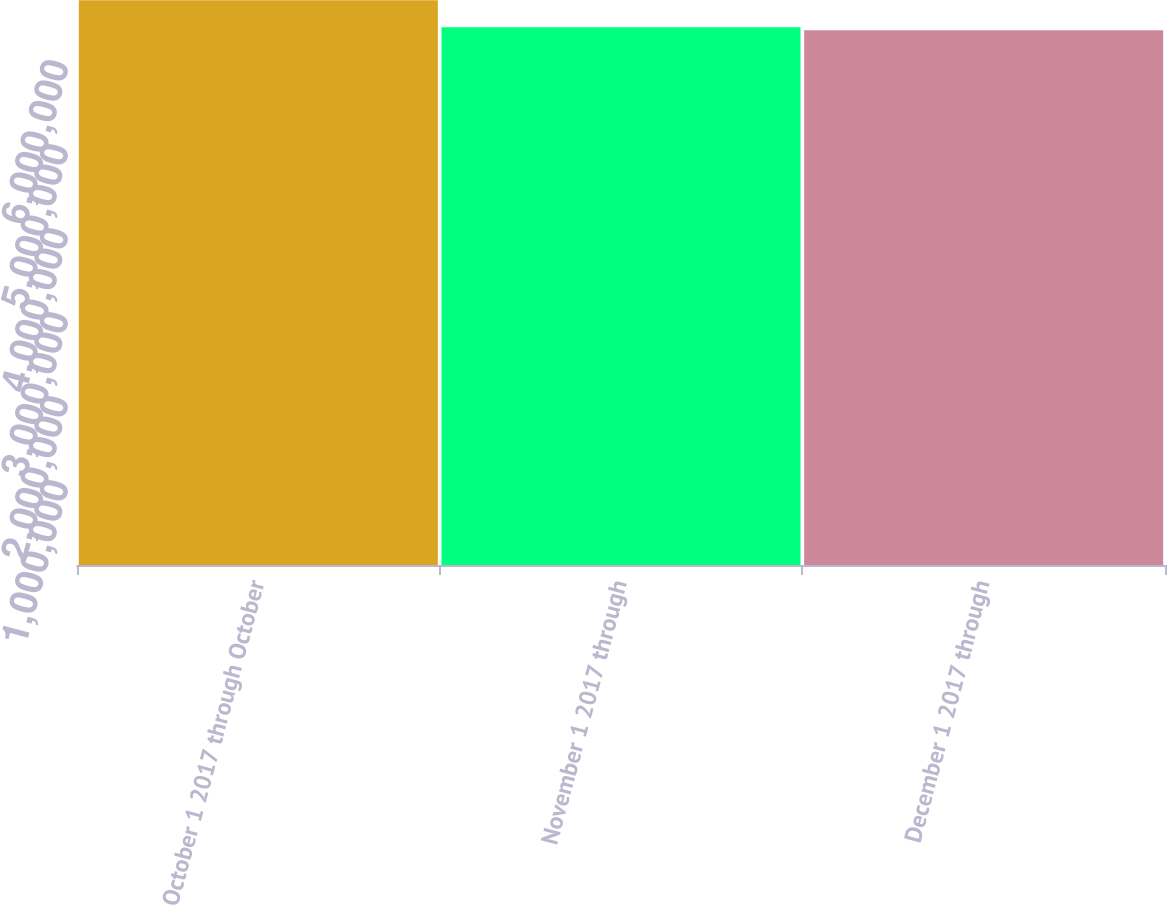Convert chart to OTSL. <chart><loc_0><loc_0><loc_500><loc_500><bar_chart><fcel>October 1 2017 through October<fcel>November 1 2017 through<fcel>December 1 2017 through<nl><fcel>6.7238e+06<fcel>6.40284e+06<fcel>6.36717e+06<nl></chart> 